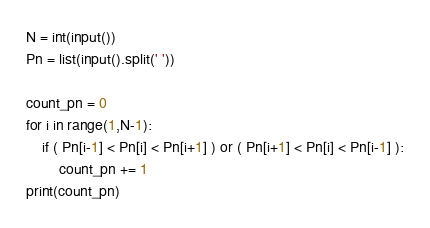<code> <loc_0><loc_0><loc_500><loc_500><_Python_>N = int(input())
Pn = list(input().split(' '))

count_pn = 0
for i in range(1,N-1):
    if ( Pn[i-1] < Pn[i] < Pn[i+1] ) or ( Pn[i+1] < Pn[i] < Pn[i-1] ):
        count_pn += 1
print(count_pn)
</code> 